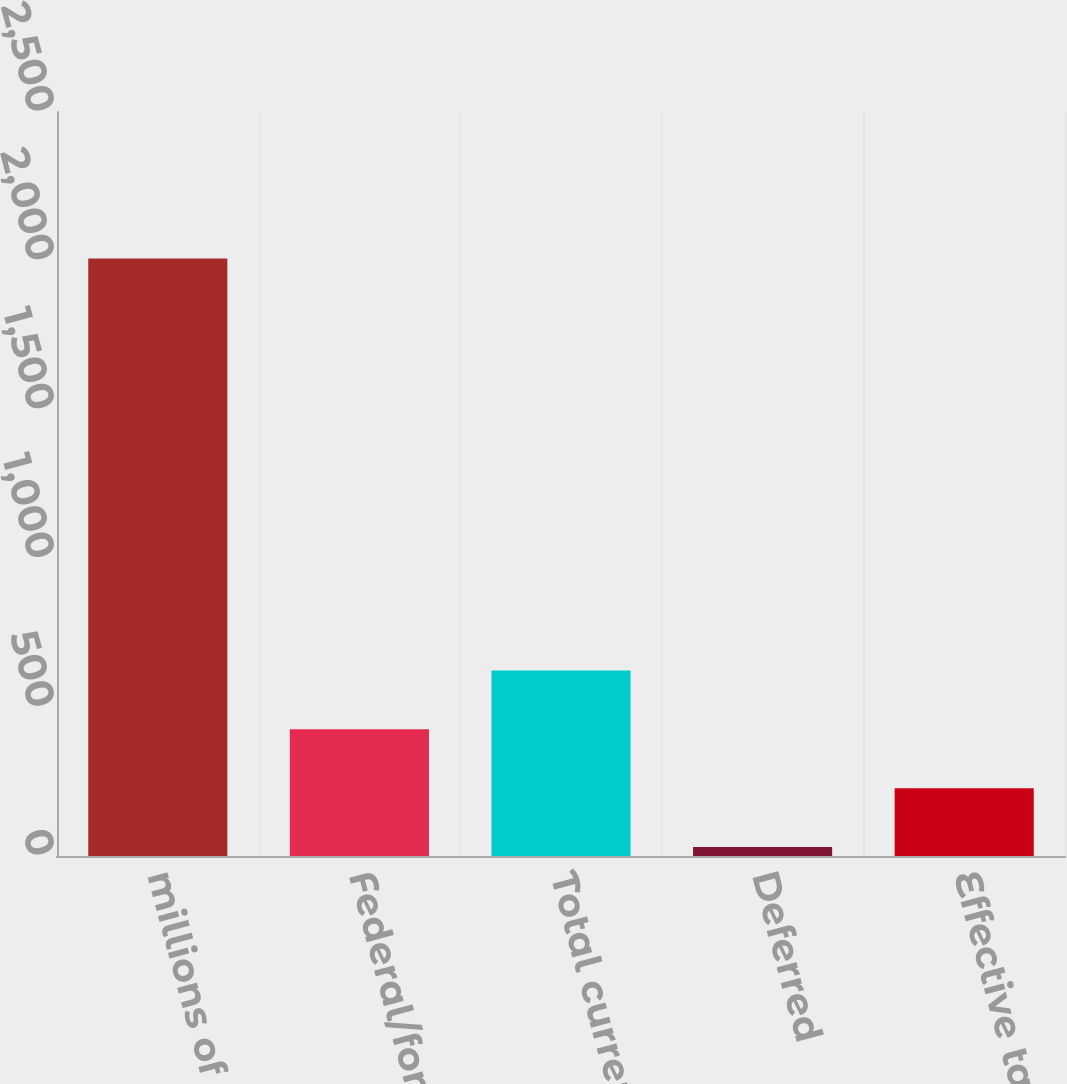<chart> <loc_0><loc_0><loc_500><loc_500><bar_chart><fcel>millions of dollars<fcel>Federal/foreign<fcel>Total current<fcel>Deferred<fcel>Effective tax rate<nl><fcel>2008<fcel>425.76<fcel>623.54<fcel>30.2<fcel>227.98<nl></chart> 